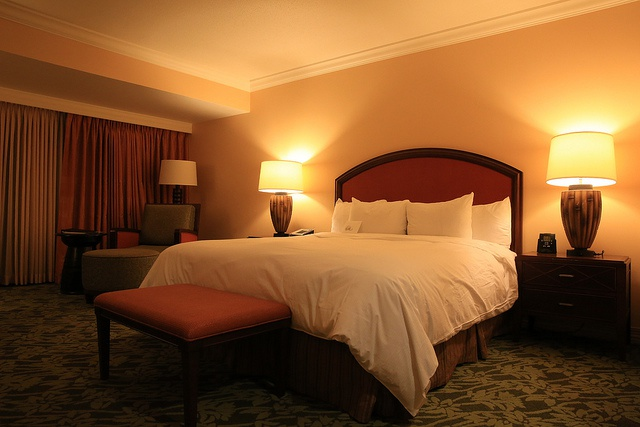Describe the objects in this image and their specific colors. I can see bed in maroon, tan, black, and brown tones and chair in maroon and black tones in this image. 